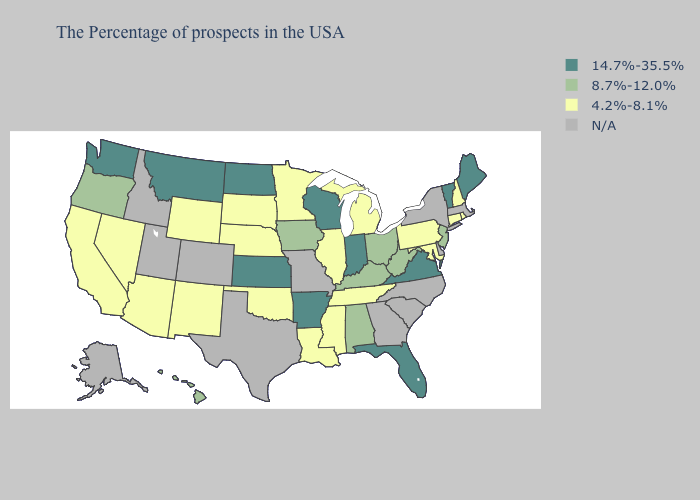What is the value of New Hampshire?
Answer briefly. 4.2%-8.1%. Name the states that have a value in the range 8.7%-12.0%?
Quick response, please. New Jersey, West Virginia, Ohio, Kentucky, Alabama, Iowa, Oregon, Hawaii. Name the states that have a value in the range 14.7%-35.5%?
Write a very short answer. Maine, Vermont, Virginia, Florida, Indiana, Wisconsin, Arkansas, Kansas, North Dakota, Montana, Washington. Among the states that border Pennsylvania , which have the highest value?
Answer briefly. New Jersey, West Virginia, Ohio. What is the value of New Jersey?
Answer briefly. 8.7%-12.0%. What is the value of Alaska?
Answer briefly. N/A. Name the states that have a value in the range 4.2%-8.1%?
Concise answer only. Rhode Island, New Hampshire, Connecticut, Maryland, Pennsylvania, Michigan, Tennessee, Illinois, Mississippi, Louisiana, Minnesota, Nebraska, Oklahoma, South Dakota, Wyoming, New Mexico, Arizona, Nevada, California. What is the value of Louisiana?
Quick response, please. 4.2%-8.1%. Does the first symbol in the legend represent the smallest category?
Short answer required. No. Name the states that have a value in the range 8.7%-12.0%?
Keep it brief. New Jersey, West Virginia, Ohio, Kentucky, Alabama, Iowa, Oregon, Hawaii. Name the states that have a value in the range 4.2%-8.1%?
Quick response, please. Rhode Island, New Hampshire, Connecticut, Maryland, Pennsylvania, Michigan, Tennessee, Illinois, Mississippi, Louisiana, Minnesota, Nebraska, Oklahoma, South Dakota, Wyoming, New Mexico, Arizona, Nevada, California. Among the states that border Maryland , which have the highest value?
Write a very short answer. Virginia. Does Montana have the lowest value in the USA?
Answer briefly. No. What is the lowest value in the Northeast?
Give a very brief answer. 4.2%-8.1%. 